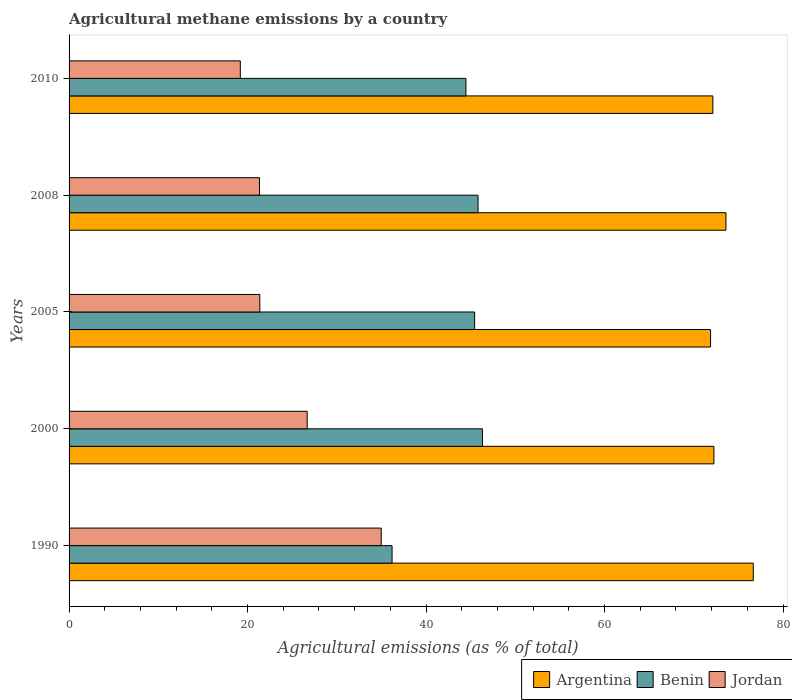How many different coloured bars are there?
Keep it short and to the point. 3. How many groups of bars are there?
Your answer should be compact. 5. Are the number of bars per tick equal to the number of legend labels?
Keep it short and to the point. Yes. How many bars are there on the 3rd tick from the top?
Offer a very short reply. 3. What is the label of the 2nd group of bars from the top?
Provide a short and direct response. 2008. What is the amount of agricultural methane emitted in Argentina in 2010?
Offer a very short reply. 72.14. Across all years, what is the maximum amount of agricultural methane emitted in Benin?
Your response must be concise. 46.32. Across all years, what is the minimum amount of agricultural methane emitted in Argentina?
Offer a very short reply. 71.88. In which year was the amount of agricultural methane emitted in Benin minimum?
Your answer should be compact. 1990. What is the total amount of agricultural methane emitted in Benin in the graph?
Your response must be concise. 218.26. What is the difference between the amount of agricultural methane emitted in Benin in 2000 and that in 2010?
Offer a terse response. 1.85. What is the difference between the amount of agricultural methane emitted in Argentina in 2000 and the amount of agricultural methane emitted in Jordan in 2008?
Your answer should be compact. 50.92. What is the average amount of agricultural methane emitted in Benin per year?
Provide a short and direct response. 43.65. In the year 1990, what is the difference between the amount of agricultural methane emitted in Argentina and amount of agricultural methane emitted in Benin?
Make the answer very short. 40.47. In how many years, is the amount of agricultural methane emitted in Argentina greater than 64 %?
Offer a very short reply. 5. What is the ratio of the amount of agricultural methane emitted in Jordan in 2005 to that in 2010?
Your response must be concise. 1.11. What is the difference between the highest and the second highest amount of agricultural methane emitted in Jordan?
Your answer should be compact. 8.3. What is the difference between the highest and the lowest amount of agricultural methane emitted in Benin?
Your answer should be compact. 10.13. Is the sum of the amount of agricultural methane emitted in Jordan in 1990 and 2000 greater than the maximum amount of agricultural methane emitted in Argentina across all years?
Give a very brief answer. No. What does the 3rd bar from the top in 2005 represents?
Your response must be concise. Argentina. Are all the bars in the graph horizontal?
Offer a terse response. Yes. Where does the legend appear in the graph?
Offer a very short reply. Bottom right. How many legend labels are there?
Offer a very short reply. 3. What is the title of the graph?
Provide a succinct answer. Agricultural methane emissions by a country. What is the label or title of the X-axis?
Provide a succinct answer. Agricultural emissions (as % of total). What is the Agricultural emissions (as % of total) of Argentina in 1990?
Offer a terse response. 76.67. What is the Agricultural emissions (as % of total) in Benin in 1990?
Provide a succinct answer. 36.19. What is the Agricultural emissions (as % of total) in Jordan in 1990?
Make the answer very short. 34.98. What is the Agricultural emissions (as % of total) of Argentina in 2000?
Offer a terse response. 72.26. What is the Agricultural emissions (as % of total) in Benin in 2000?
Your response must be concise. 46.32. What is the Agricultural emissions (as % of total) of Jordan in 2000?
Keep it short and to the point. 26.68. What is the Agricultural emissions (as % of total) in Argentina in 2005?
Your answer should be very brief. 71.88. What is the Agricultural emissions (as % of total) in Benin in 2005?
Your answer should be compact. 45.44. What is the Agricultural emissions (as % of total) of Jordan in 2005?
Your response must be concise. 21.37. What is the Agricultural emissions (as % of total) of Argentina in 2008?
Provide a short and direct response. 73.61. What is the Agricultural emissions (as % of total) in Benin in 2008?
Your response must be concise. 45.83. What is the Agricultural emissions (as % of total) in Jordan in 2008?
Your answer should be compact. 21.34. What is the Agricultural emissions (as % of total) of Argentina in 2010?
Provide a short and direct response. 72.14. What is the Agricultural emissions (as % of total) in Benin in 2010?
Your response must be concise. 44.47. What is the Agricultural emissions (as % of total) of Jordan in 2010?
Keep it short and to the point. 19.19. Across all years, what is the maximum Agricultural emissions (as % of total) in Argentina?
Your answer should be compact. 76.67. Across all years, what is the maximum Agricultural emissions (as % of total) in Benin?
Provide a succinct answer. 46.32. Across all years, what is the maximum Agricultural emissions (as % of total) of Jordan?
Your answer should be very brief. 34.98. Across all years, what is the minimum Agricultural emissions (as % of total) of Argentina?
Your answer should be compact. 71.88. Across all years, what is the minimum Agricultural emissions (as % of total) in Benin?
Offer a terse response. 36.19. Across all years, what is the minimum Agricultural emissions (as % of total) of Jordan?
Your answer should be compact. 19.19. What is the total Agricultural emissions (as % of total) of Argentina in the graph?
Your answer should be very brief. 366.56. What is the total Agricultural emissions (as % of total) of Benin in the graph?
Make the answer very short. 218.26. What is the total Agricultural emissions (as % of total) in Jordan in the graph?
Keep it short and to the point. 123.56. What is the difference between the Agricultural emissions (as % of total) of Argentina in 1990 and that in 2000?
Provide a succinct answer. 4.41. What is the difference between the Agricultural emissions (as % of total) of Benin in 1990 and that in 2000?
Offer a terse response. -10.13. What is the difference between the Agricultural emissions (as % of total) of Jordan in 1990 and that in 2000?
Your response must be concise. 8.3. What is the difference between the Agricultural emissions (as % of total) of Argentina in 1990 and that in 2005?
Provide a succinct answer. 4.79. What is the difference between the Agricultural emissions (as % of total) in Benin in 1990 and that in 2005?
Your answer should be compact. -9.25. What is the difference between the Agricultural emissions (as % of total) of Jordan in 1990 and that in 2005?
Make the answer very short. 13.61. What is the difference between the Agricultural emissions (as % of total) in Argentina in 1990 and that in 2008?
Ensure brevity in your answer.  3.06. What is the difference between the Agricultural emissions (as % of total) in Benin in 1990 and that in 2008?
Make the answer very short. -9.63. What is the difference between the Agricultural emissions (as % of total) in Jordan in 1990 and that in 2008?
Offer a very short reply. 13.64. What is the difference between the Agricultural emissions (as % of total) of Argentina in 1990 and that in 2010?
Ensure brevity in your answer.  4.53. What is the difference between the Agricultural emissions (as % of total) of Benin in 1990 and that in 2010?
Make the answer very short. -8.28. What is the difference between the Agricultural emissions (as % of total) in Jordan in 1990 and that in 2010?
Provide a succinct answer. 15.79. What is the difference between the Agricultural emissions (as % of total) of Argentina in 2000 and that in 2005?
Offer a terse response. 0.38. What is the difference between the Agricultural emissions (as % of total) of Benin in 2000 and that in 2005?
Your answer should be compact. 0.88. What is the difference between the Agricultural emissions (as % of total) of Jordan in 2000 and that in 2005?
Your answer should be very brief. 5.31. What is the difference between the Agricultural emissions (as % of total) of Argentina in 2000 and that in 2008?
Provide a succinct answer. -1.35. What is the difference between the Agricultural emissions (as % of total) in Benin in 2000 and that in 2008?
Ensure brevity in your answer.  0.5. What is the difference between the Agricultural emissions (as % of total) in Jordan in 2000 and that in 2008?
Provide a short and direct response. 5.34. What is the difference between the Agricultural emissions (as % of total) in Argentina in 2000 and that in 2010?
Provide a succinct answer. 0.12. What is the difference between the Agricultural emissions (as % of total) in Benin in 2000 and that in 2010?
Provide a short and direct response. 1.85. What is the difference between the Agricultural emissions (as % of total) in Jordan in 2000 and that in 2010?
Your response must be concise. 7.49. What is the difference between the Agricultural emissions (as % of total) in Argentina in 2005 and that in 2008?
Your answer should be compact. -1.72. What is the difference between the Agricultural emissions (as % of total) of Benin in 2005 and that in 2008?
Your answer should be very brief. -0.38. What is the difference between the Agricultural emissions (as % of total) of Jordan in 2005 and that in 2008?
Provide a short and direct response. 0.04. What is the difference between the Agricultural emissions (as % of total) of Argentina in 2005 and that in 2010?
Make the answer very short. -0.26. What is the difference between the Agricultural emissions (as % of total) in Benin in 2005 and that in 2010?
Your response must be concise. 0.97. What is the difference between the Agricultural emissions (as % of total) of Jordan in 2005 and that in 2010?
Offer a terse response. 2.18. What is the difference between the Agricultural emissions (as % of total) of Argentina in 2008 and that in 2010?
Offer a terse response. 1.47. What is the difference between the Agricultural emissions (as % of total) in Benin in 2008 and that in 2010?
Offer a terse response. 1.36. What is the difference between the Agricultural emissions (as % of total) of Jordan in 2008 and that in 2010?
Give a very brief answer. 2.15. What is the difference between the Agricultural emissions (as % of total) of Argentina in 1990 and the Agricultural emissions (as % of total) of Benin in 2000?
Keep it short and to the point. 30.35. What is the difference between the Agricultural emissions (as % of total) in Argentina in 1990 and the Agricultural emissions (as % of total) in Jordan in 2000?
Your answer should be very brief. 49.99. What is the difference between the Agricultural emissions (as % of total) in Benin in 1990 and the Agricultural emissions (as % of total) in Jordan in 2000?
Offer a terse response. 9.52. What is the difference between the Agricultural emissions (as % of total) of Argentina in 1990 and the Agricultural emissions (as % of total) of Benin in 2005?
Keep it short and to the point. 31.23. What is the difference between the Agricultural emissions (as % of total) in Argentina in 1990 and the Agricultural emissions (as % of total) in Jordan in 2005?
Your answer should be compact. 55.3. What is the difference between the Agricultural emissions (as % of total) in Benin in 1990 and the Agricultural emissions (as % of total) in Jordan in 2005?
Keep it short and to the point. 14.82. What is the difference between the Agricultural emissions (as % of total) in Argentina in 1990 and the Agricultural emissions (as % of total) in Benin in 2008?
Offer a terse response. 30.84. What is the difference between the Agricultural emissions (as % of total) in Argentina in 1990 and the Agricultural emissions (as % of total) in Jordan in 2008?
Provide a short and direct response. 55.33. What is the difference between the Agricultural emissions (as % of total) in Benin in 1990 and the Agricultural emissions (as % of total) in Jordan in 2008?
Provide a short and direct response. 14.86. What is the difference between the Agricultural emissions (as % of total) in Argentina in 1990 and the Agricultural emissions (as % of total) in Benin in 2010?
Offer a very short reply. 32.2. What is the difference between the Agricultural emissions (as % of total) in Argentina in 1990 and the Agricultural emissions (as % of total) in Jordan in 2010?
Offer a terse response. 57.48. What is the difference between the Agricultural emissions (as % of total) of Benin in 1990 and the Agricultural emissions (as % of total) of Jordan in 2010?
Make the answer very short. 17.01. What is the difference between the Agricultural emissions (as % of total) of Argentina in 2000 and the Agricultural emissions (as % of total) of Benin in 2005?
Your answer should be very brief. 26.82. What is the difference between the Agricultural emissions (as % of total) in Argentina in 2000 and the Agricultural emissions (as % of total) in Jordan in 2005?
Give a very brief answer. 50.89. What is the difference between the Agricultural emissions (as % of total) of Benin in 2000 and the Agricultural emissions (as % of total) of Jordan in 2005?
Your answer should be very brief. 24.95. What is the difference between the Agricultural emissions (as % of total) in Argentina in 2000 and the Agricultural emissions (as % of total) in Benin in 2008?
Provide a short and direct response. 26.43. What is the difference between the Agricultural emissions (as % of total) of Argentina in 2000 and the Agricultural emissions (as % of total) of Jordan in 2008?
Give a very brief answer. 50.92. What is the difference between the Agricultural emissions (as % of total) of Benin in 2000 and the Agricultural emissions (as % of total) of Jordan in 2008?
Your response must be concise. 24.99. What is the difference between the Agricultural emissions (as % of total) of Argentina in 2000 and the Agricultural emissions (as % of total) of Benin in 2010?
Your answer should be compact. 27.79. What is the difference between the Agricultural emissions (as % of total) of Argentina in 2000 and the Agricultural emissions (as % of total) of Jordan in 2010?
Offer a very short reply. 53.07. What is the difference between the Agricultural emissions (as % of total) of Benin in 2000 and the Agricultural emissions (as % of total) of Jordan in 2010?
Provide a succinct answer. 27.13. What is the difference between the Agricultural emissions (as % of total) in Argentina in 2005 and the Agricultural emissions (as % of total) in Benin in 2008?
Your response must be concise. 26.06. What is the difference between the Agricultural emissions (as % of total) of Argentina in 2005 and the Agricultural emissions (as % of total) of Jordan in 2008?
Keep it short and to the point. 50.55. What is the difference between the Agricultural emissions (as % of total) in Benin in 2005 and the Agricultural emissions (as % of total) in Jordan in 2008?
Your answer should be very brief. 24.11. What is the difference between the Agricultural emissions (as % of total) in Argentina in 2005 and the Agricultural emissions (as % of total) in Benin in 2010?
Provide a short and direct response. 27.41. What is the difference between the Agricultural emissions (as % of total) in Argentina in 2005 and the Agricultural emissions (as % of total) in Jordan in 2010?
Offer a terse response. 52.69. What is the difference between the Agricultural emissions (as % of total) of Benin in 2005 and the Agricultural emissions (as % of total) of Jordan in 2010?
Provide a short and direct response. 26.26. What is the difference between the Agricultural emissions (as % of total) in Argentina in 2008 and the Agricultural emissions (as % of total) in Benin in 2010?
Your response must be concise. 29.14. What is the difference between the Agricultural emissions (as % of total) of Argentina in 2008 and the Agricultural emissions (as % of total) of Jordan in 2010?
Provide a succinct answer. 54.42. What is the difference between the Agricultural emissions (as % of total) of Benin in 2008 and the Agricultural emissions (as % of total) of Jordan in 2010?
Keep it short and to the point. 26.64. What is the average Agricultural emissions (as % of total) of Argentina per year?
Ensure brevity in your answer.  73.31. What is the average Agricultural emissions (as % of total) in Benin per year?
Give a very brief answer. 43.65. What is the average Agricultural emissions (as % of total) of Jordan per year?
Keep it short and to the point. 24.71. In the year 1990, what is the difference between the Agricultural emissions (as % of total) of Argentina and Agricultural emissions (as % of total) of Benin?
Provide a short and direct response. 40.47. In the year 1990, what is the difference between the Agricultural emissions (as % of total) of Argentina and Agricultural emissions (as % of total) of Jordan?
Your answer should be compact. 41.69. In the year 1990, what is the difference between the Agricultural emissions (as % of total) of Benin and Agricultural emissions (as % of total) of Jordan?
Give a very brief answer. 1.22. In the year 2000, what is the difference between the Agricultural emissions (as % of total) of Argentina and Agricultural emissions (as % of total) of Benin?
Your answer should be very brief. 25.94. In the year 2000, what is the difference between the Agricultural emissions (as % of total) in Argentina and Agricultural emissions (as % of total) in Jordan?
Offer a very short reply. 45.58. In the year 2000, what is the difference between the Agricultural emissions (as % of total) of Benin and Agricultural emissions (as % of total) of Jordan?
Offer a terse response. 19.64. In the year 2005, what is the difference between the Agricultural emissions (as % of total) of Argentina and Agricultural emissions (as % of total) of Benin?
Your answer should be compact. 26.44. In the year 2005, what is the difference between the Agricultural emissions (as % of total) of Argentina and Agricultural emissions (as % of total) of Jordan?
Offer a terse response. 50.51. In the year 2005, what is the difference between the Agricultural emissions (as % of total) in Benin and Agricultural emissions (as % of total) in Jordan?
Provide a short and direct response. 24.07. In the year 2008, what is the difference between the Agricultural emissions (as % of total) of Argentina and Agricultural emissions (as % of total) of Benin?
Provide a succinct answer. 27.78. In the year 2008, what is the difference between the Agricultural emissions (as % of total) in Argentina and Agricultural emissions (as % of total) in Jordan?
Provide a succinct answer. 52.27. In the year 2008, what is the difference between the Agricultural emissions (as % of total) of Benin and Agricultural emissions (as % of total) of Jordan?
Ensure brevity in your answer.  24.49. In the year 2010, what is the difference between the Agricultural emissions (as % of total) of Argentina and Agricultural emissions (as % of total) of Benin?
Provide a succinct answer. 27.67. In the year 2010, what is the difference between the Agricultural emissions (as % of total) of Argentina and Agricultural emissions (as % of total) of Jordan?
Your answer should be very brief. 52.95. In the year 2010, what is the difference between the Agricultural emissions (as % of total) of Benin and Agricultural emissions (as % of total) of Jordan?
Your answer should be compact. 25.28. What is the ratio of the Agricultural emissions (as % of total) of Argentina in 1990 to that in 2000?
Keep it short and to the point. 1.06. What is the ratio of the Agricultural emissions (as % of total) in Benin in 1990 to that in 2000?
Your answer should be very brief. 0.78. What is the ratio of the Agricultural emissions (as % of total) in Jordan in 1990 to that in 2000?
Offer a terse response. 1.31. What is the ratio of the Agricultural emissions (as % of total) in Argentina in 1990 to that in 2005?
Ensure brevity in your answer.  1.07. What is the ratio of the Agricultural emissions (as % of total) of Benin in 1990 to that in 2005?
Give a very brief answer. 0.8. What is the ratio of the Agricultural emissions (as % of total) in Jordan in 1990 to that in 2005?
Ensure brevity in your answer.  1.64. What is the ratio of the Agricultural emissions (as % of total) of Argentina in 1990 to that in 2008?
Your answer should be very brief. 1.04. What is the ratio of the Agricultural emissions (as % of total) in Benin in 1990 to that in 2008?
Offer a terse response. 0.79. What is the ratio of the Agricultural emissions (as % of total) of Jordan in 1990 to that in 2008?
Offer a very short reply. 1.64. What is the ratio of the Agricultural emissions (as % of total) in Argentina in 1990 to that in 2010?
Offer a terse response. 1.06. What is the ratio of the Agricultural emissions (as % of total) of Benin in 1990 to that in 2010?
Give a very brief answer. 0.81. What is the ratio of the Agricultural emissions (as % of total) of Jordan in 1990 to that in 2010?
Provide a succinct answer. 1.82. What is the ratio of the Agricultural emissions (as % of total) in Argentina in 2000 to that in 2005?
Offer a very short reply. 1.01. What is the ratio of the Agricultural emissions (as % of total) in Benin in 2000 to that in 2005?
Offer a terse response. 1.02. What is the ratio of the Agricultural emissions (as % of total) in Jordan in 2000 to that in 2005?
Provide a short and direct response. 1.25. What is the ratio of the Agricultural emissions (as % of total) in Argentina in 2000 to that in 2008?
Offer a terse response. 0.98. What is the ratio of the Agricultural emissions (as % of total) in Benin in 2000 to that in 2008?
Ensure brevity in your answer.  1.01. What is the ratio of the Agricultural emissions (as % of total) of Jordan in 2000 to that in 2008?
Provide a succinct answer. 1.25. What is the ratio of the Agricultural emissions (as % of total) in Argentina in 2000 to that in 2010?
Offer a very short reply. 1. What is the ratio of the Agricultural emissions (as % of total) in Benin in 2000 to that in 2010?
Your answer should be very brief. 1.04. What is the ratio of the Agricultural emissions (as % of total) of Jordan in 2000 to that in 2010?
Keep it short and to the point. 1.39. What is the ratio of the Agricultural emissions (as % of total) of Argentina in 2005 to that in 2008?
Your answer should be very brief. 0.98. What is the ratio of the Agricultural emissions (as % of total) of Benin in 2005 to that in 2008?
Offer a terse response. 0.99. What is the ratio of the Agricultural emissions (as % of total) in Argentina in 2005 to that in 2010?
Offer a very short reply. 1. What is the ratio of the Agricultural emissions (as % of total) of Benin in 2005 to that in 2010?
Your answer should be very brief. 1.02. What is the ratio of the Agricultural emissions (as % of total) of Jordan in 2005 to that in 2010?
Provide a short and direct response. 1.11. What is the ratio of the Agricultural emissions (as % of total) in Argentina in 2008 to that in 2010?
Give a very brief answer. 1.02. What is the ratio of the Agricultural emissions (as % of total) in Benin in 2008 to that in 2010?
Give a very brief answer. 1.03. What is the ratio of the Agricultural emissions (as % of total) of Jordan in 2008 to that in 2010?
Give a very brief answer. 1.11. What is the difference between the highest and the second highest Agricultural emissions (as % of total) of Argentina?
Give a very brief answer. 3.06. What is the difference between the highest and the second highest Agricultural emissions (as % of total) of Benin?
Provide a succinct answer. 0.5. What is the difference between the highest and the second highest Agricultural emissions (as % of total) in Jordan?
Offer a very short reply. 8.3. What is the difference between the highest and the lowest Agricultural emissions (as % of total) in Argentina?
Your answer should be compact. 4.79. What is the difference between the highest and the lowest Agricultural emissions (as % of total) in Benin?
Offer a terse response. 10.13. What is the difference between the highest and the lowest Agricultural emissions (as % of total) of Jordan?
Offer a very short reply. 15.79. 